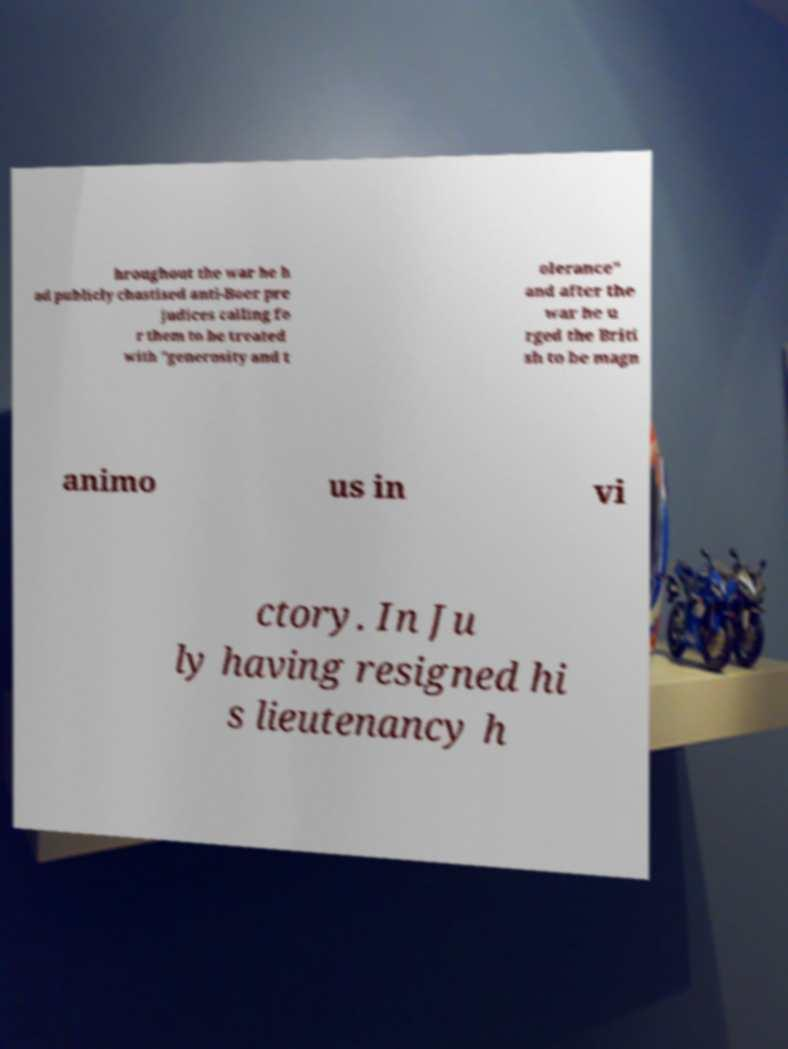Please identify and transcribe the text found in this image. hroughout the war he h ad publicly chastised anti-Boer pre judices calling fo r them to be treated with "generosity and t olerance" and after the war he u rged the Briti sh to be magn animo us in vi ctory. In Ju ly having resigned hi s lieutenancy h 